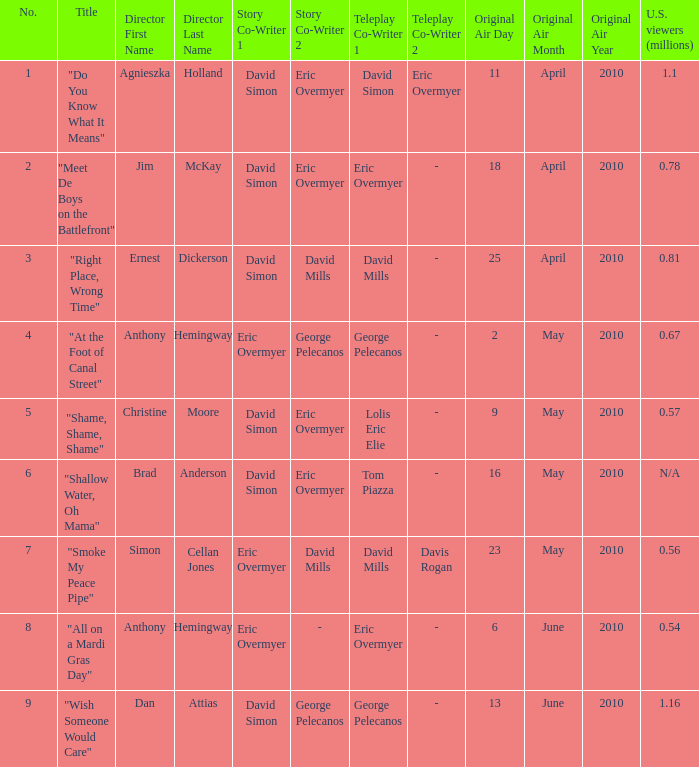Name the number for simon cellan jones 7.0. 